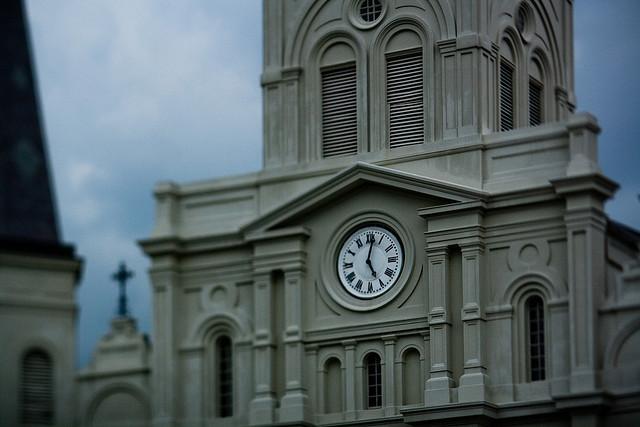What color is the clock?
Give a very brief answer. White. What time is it?
Concise answer only. 5:01. What is the time on the clock?
Quick response, please. 5:03. What time is it in the photo?
Answer briefly. 5:02. How many clocks?
Concise answer only. 1. Is the time 5:02 PM?
Be succinct. Yes. What is the building made of?
Be succinct. Stone. What is the time?
Keep it brief. 5:02. What time is shown?
Short answer required. 5:02. Are there numbers or Roman numerals on the clock face?
Give a very brief answer. Yes. Is this a church?
Answer briefly. Yes. What does the clock read?
Quick response, please. 5:00. How many spires does the building have?
Answer briefly. 1. Is this a close up?
Write a very short answer. Yes. 